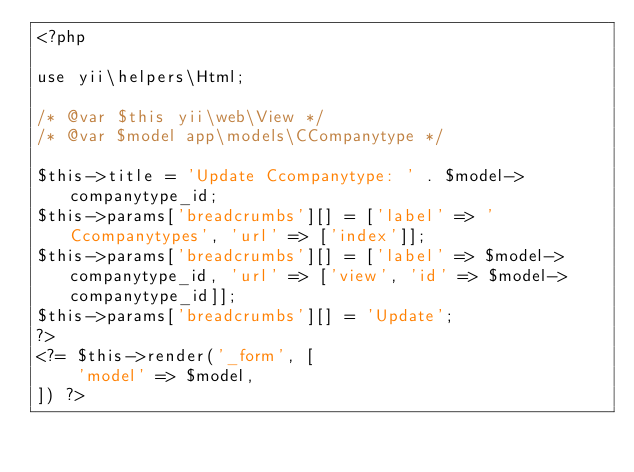Convert code to text. <code><loc_0><loc_0><loc_500><loc_500><_PHP_><?php

use yii\helpers\Html;

/* @var $this yii\web\View */
/* @var $model app\models\CCompanytype */

$this->title = 'Update Ccompanytype: ' . $model->companytype_id;
$this->params['breadcrumbs'][] = ['label' => 'Ccompanytypes', 'url' => ['index']];
$this->params['breadcrumbs'][] = ['label' => $model->companytype_id, 'url' => ['view', 'id' => $model->companytype_id]];
$this->params['breadcrumbs'][] = 'Update';
?>
<?= $this->render('_form', [
    'model' => $model,
]) ?>
</code> 